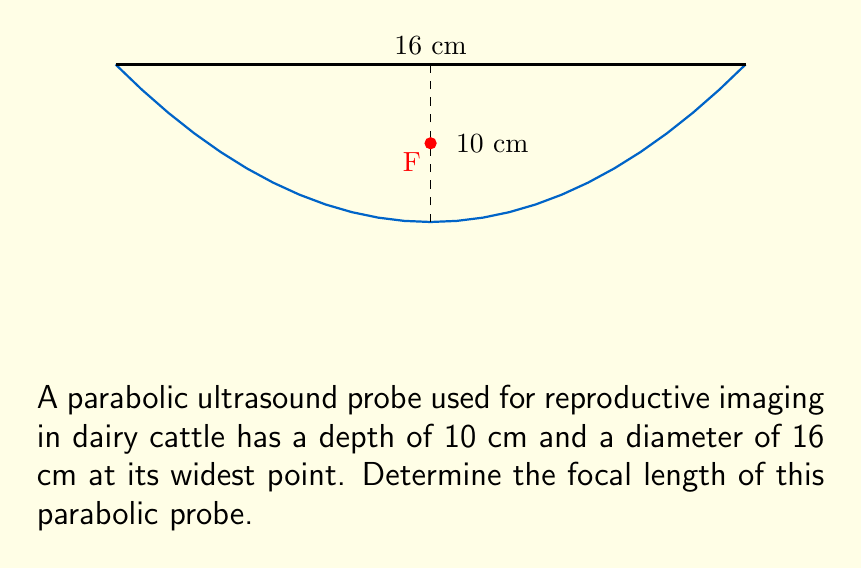Could you help me with this problem? Let's approach this step-by-step:

1) The equation of a parabola with vertex at the origin and opening upwards is:
   $$y = \frac{1}{4a}x^2$$
   where $a$ is the focal length.

2) We know the width (diameter) is 16 cm and the depth is 10 cm. Let's use these to set up our equation:
   - The width of 16 cm means the x-coordinate at the top is ±8 cm (radius).
   - The depth of 10 cm is the y-coordinate at the top.

3) Substituting these into our equation:
   $$10 = \frac{1}{4a}(8^2)$$

4) Simplify:
   $$10 = \frac{64}{4a}$$
   $$10 = \frac{16}{a}$$

5) Solve for $a$:
   $$a = \frac{16}{10} = 1.6$$

Therefore, the focal length of the parabolic probe is 1.6 cm.
Answer: 1.6 cm 